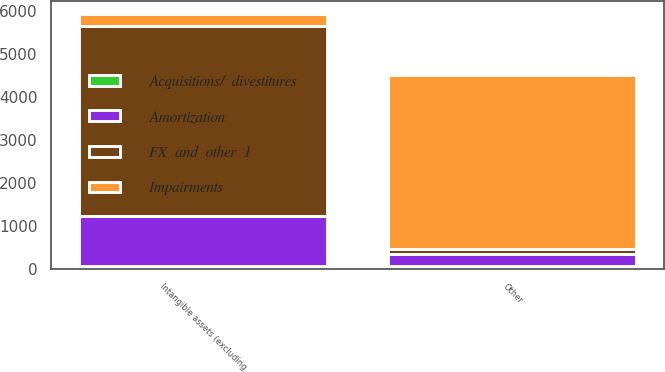<chart> <loc_0><loc_0><loc_500><loc_500><stacked_bar_chart><ecel><fcel>Other<fcel>Intangible assets (excluding<nl><fcel>Impairments<fcel>4058<fcel>292<nl><fcel>FX  and  other  1<fcel>108<fcel>4400<nl><fcel>Amortization<fcel>292<fcel>1179<nl><fcel>Acquisitions/  divestitures<fcel>53<fcel>56<nl></chart> 